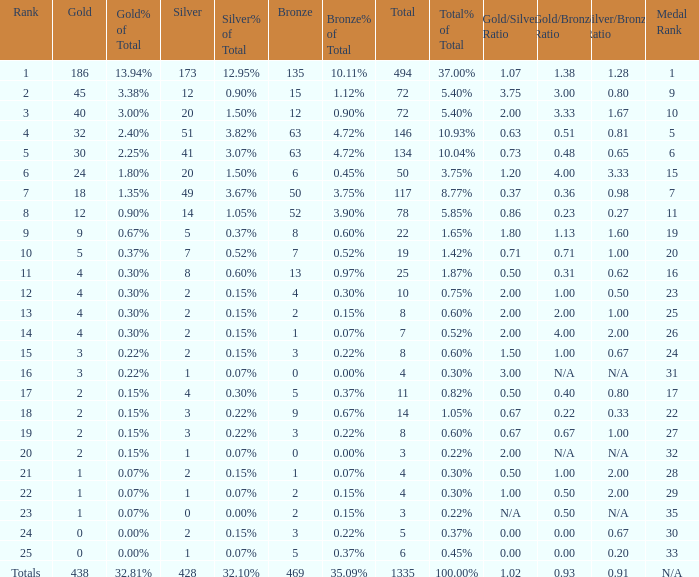What is the average number of gold medals when the total was 1335 medals, with more than 469 bronzes and more than 14 silvers? None. 